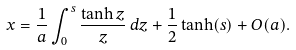<formula> <loc_0><loc_0><loc_500><loc_500>x = \frac { 1 } { a } \int _ { 0 } ^ { s } \frac { \tanh z } { z } \, d z + \frac { 1 } { 2 } \tanh ( s ) + O ( a ) .</formula> 